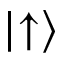<formula> <loc_0><loc_0><loc_500><loc_500>| { \uparrow } \rangle</formula> 